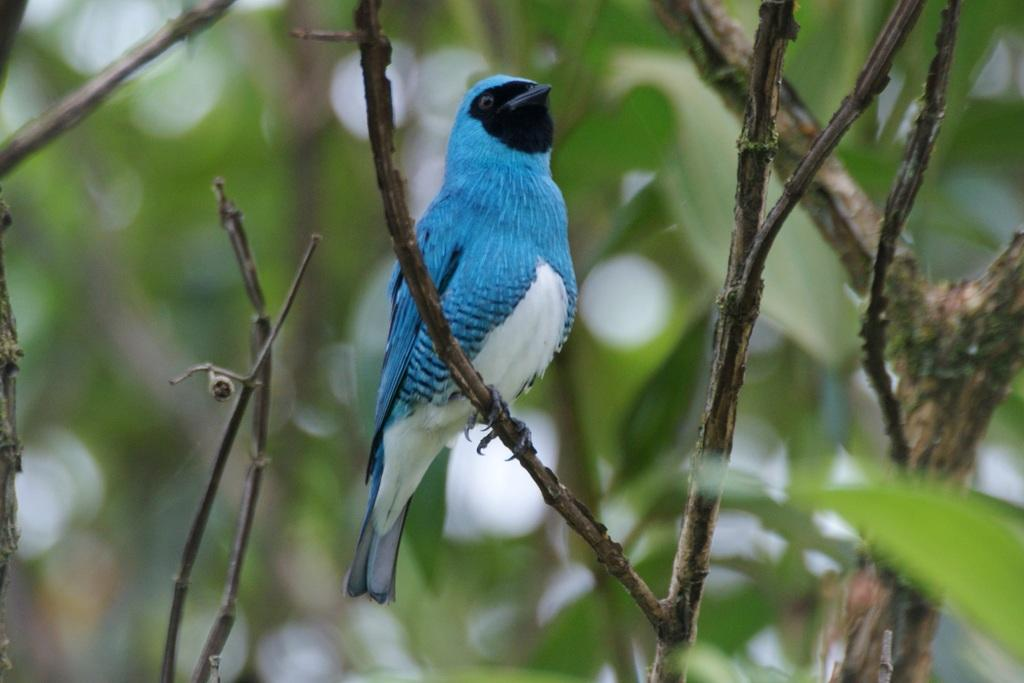What type of animal can be seen in the image? There is a bird in the image. Where is the bird located? The bird is on the stem of a tree. What else can be seen in the image besides the bird? There are trees visible in the image. Can you describe the background of the image? The background of the image is blurred. What type of silk material is being used as a cushion for the bird in the image? There is no silk material or cushion present in the image; the bird is on the stem of a tree. 